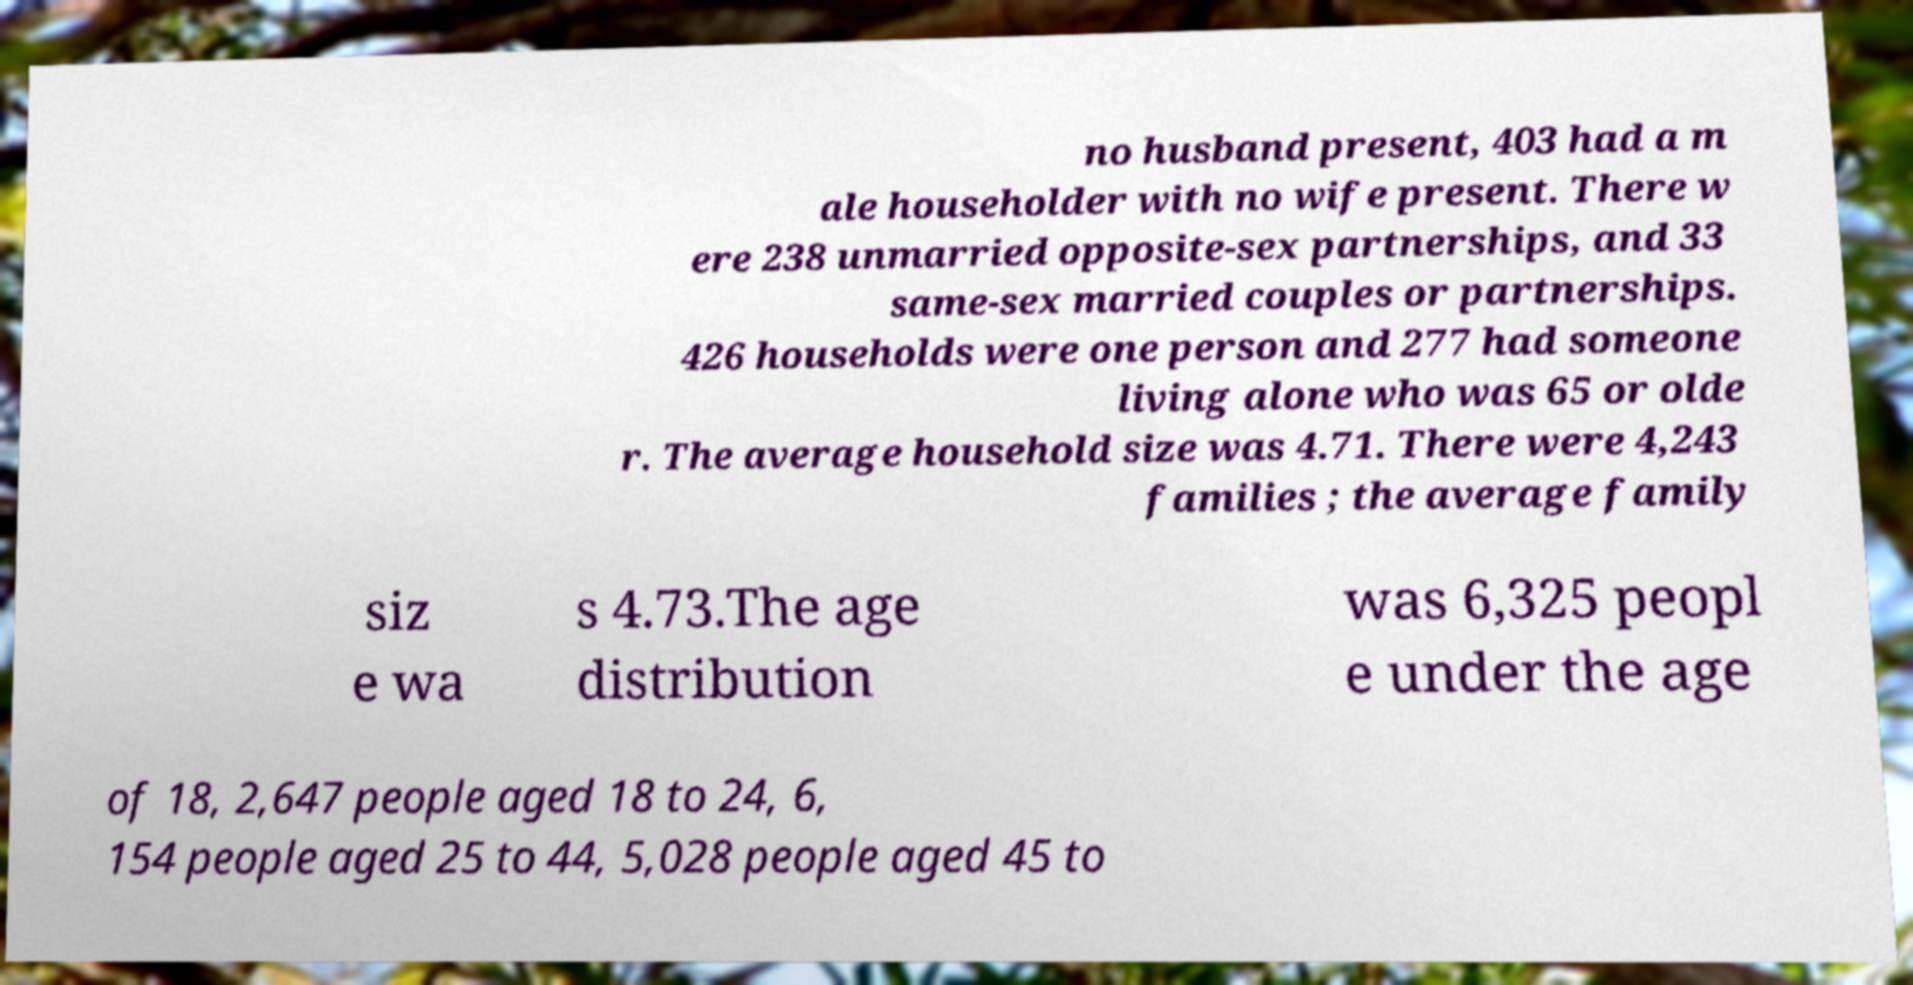Could you assist in decoding the text presented in this image and type it out clearly? no husband present, 403 had a m ale householder with no wife present. There w ere 238 unmarried opposite-sex partnerships, and 33 same-sex married couples or partnerships. 426 households were one person and 277 had someone living alone who was 65 or olde r. The average household size was 4.71. There were 4,243 families ; the average family siz e wa s 4.73.The age distribution was 6,325 peopl e under the age of 18, 2,647 people aged 18 to 24, 6, 154 people aged 25 to 44, 5,028 people aged 45 to 